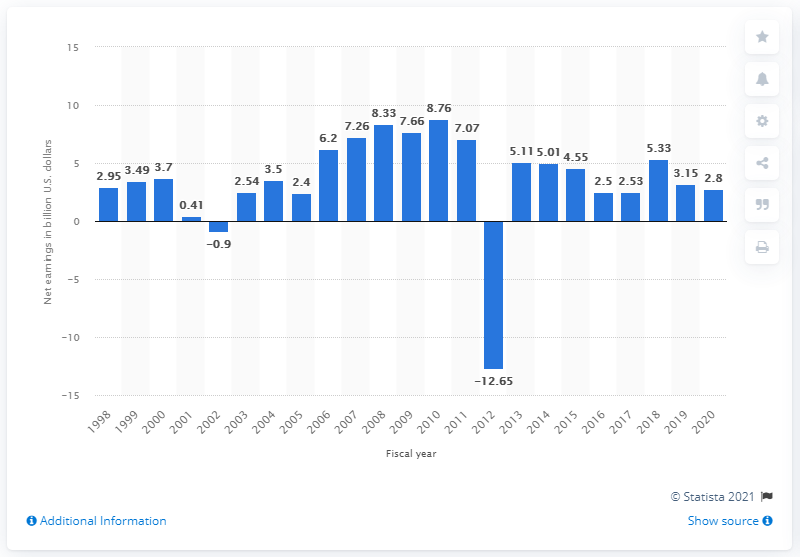Give some essential details in this illustration. During the 2020 fiscal year, HP reported net earnings of 2.8 billion dollars. In 2018, HP's net earnings were 5.33. 